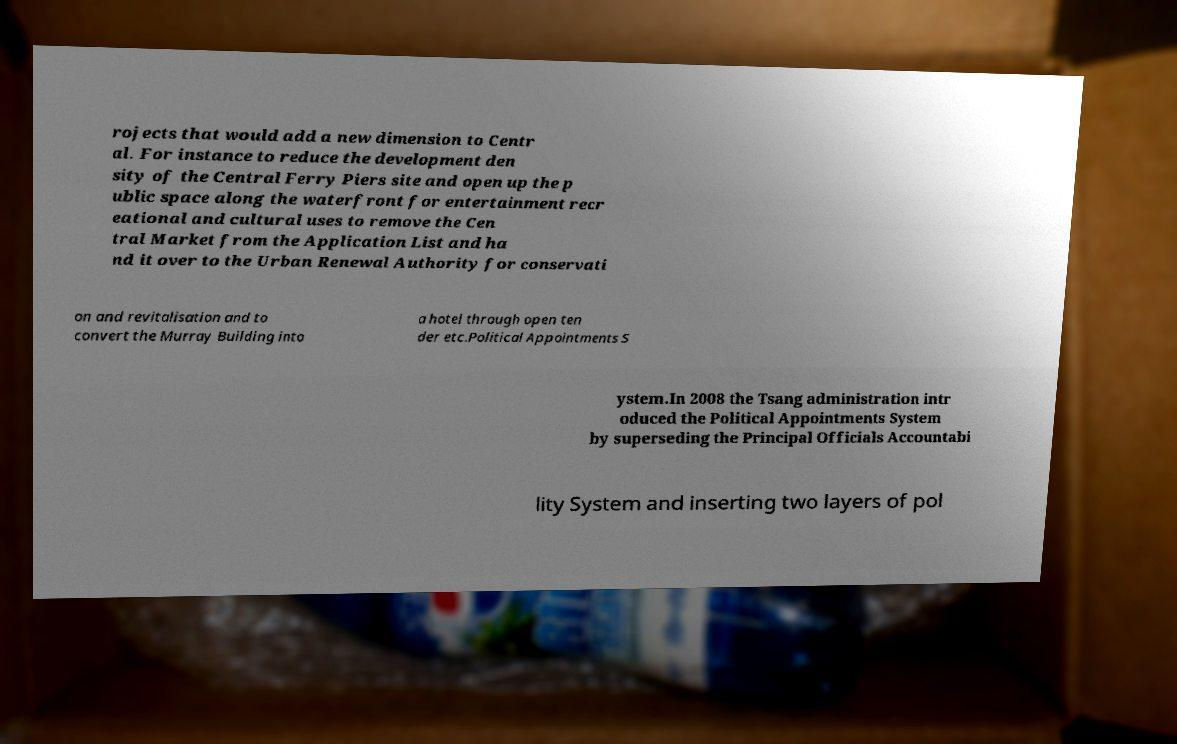What messages or text are displayed in this image? I need them in a readable, typed format. rojects that would add a new dimension to Centr al. For instance to reduce the development den sity of the Central Ferry Piers site and open up the p ublic space along the waterfront for entertainment recr eational and cultural uses to remove the Cen tral Market from the Application List and ha nd it over to the Urban Renewal Authority for conservati on and revitalisation and to convert the Murray Building into a hotel through open ten der etc.Political Appointments S ystem.In 2008 the Tsang administration intr oduced the Political Appointments System by superseding the Principal Officials Accountabi lity System and inserting two layers of pol 